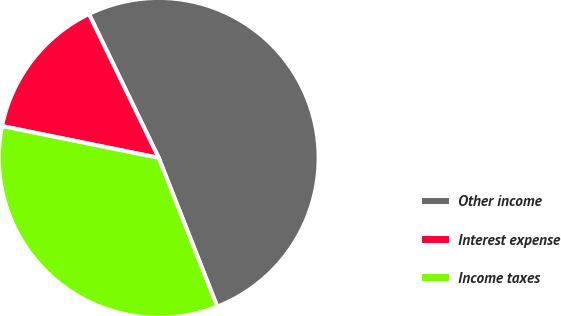Convert chart to OTSL. <chart><loc_0><loc_0><loc_500><loc_500><pie_chart><fcel>Other income<fcel>Interest expense<fcel>Income taxes<nl><fcel>51.22%<fcel>14.63%<fcel>34.15%<nl></chart> 